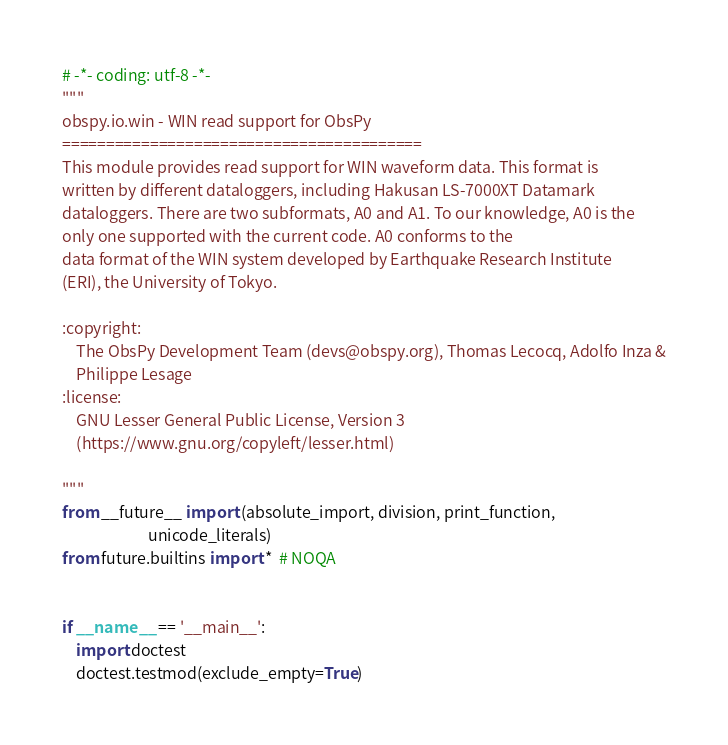<code> <loc_0><loc_0><loc_500><loc_500><_Python_># -*- coding: utf-8 -*-
"""
obspy.io.win - WIN read support for ObsPy
=========================================
This module provides read support for WIN waveform data. This format is
written by different dataloggers, including Hakusan LS-7000XT Datamark
dataloggers. There are two subformats, A0 and A1. To our knowledge, A0 is the
only one supported with the current code. A0 conforms to the
data format of the WIN system developed by Earthquake Research Institute
(ERI), the University of Tokyo.

:copyright:
    The ObsPy Development Team (devs@obspy.org), Thomas Lecocq, Adolfo Inza &
    Philippe Lesage
:license:
    GNU Lesser General Public License, Version 3
    (https://www.gnu.org/copyleft/lesser.html)

"""
from __future__ import (absolute_import, division, print_function,
                        unicode_literals)
from future.builtins import *  # NOQA


if __name__ == '__main__':
    import doctest
    doctest.testmod(exclude_empty=True)
</code> 